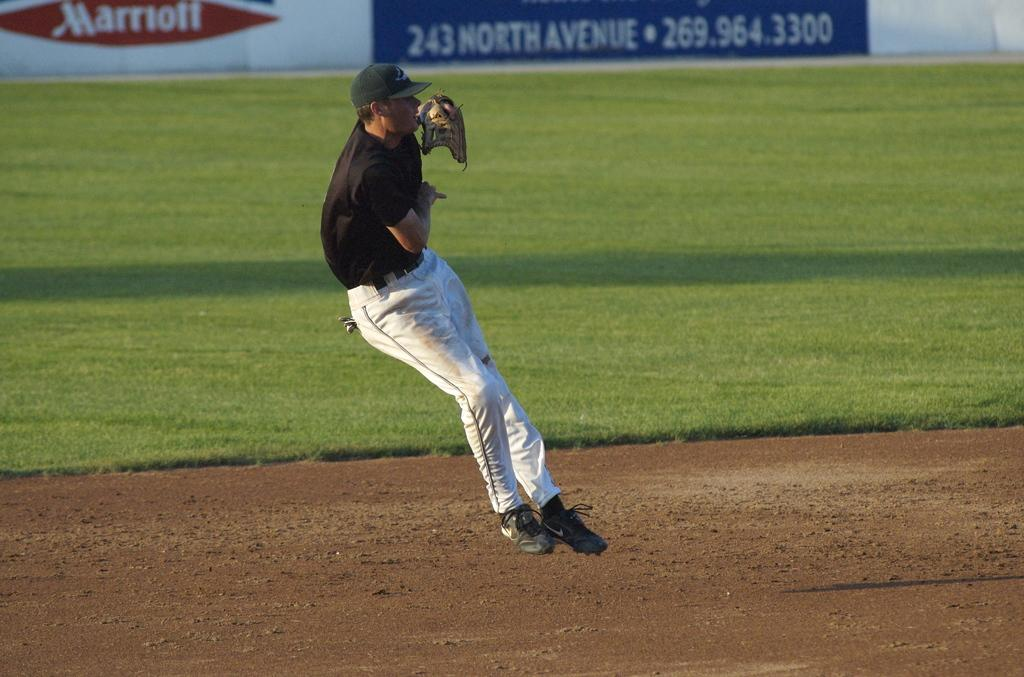<image>
Relay a brief, clear account of the picture shown. a player with a Marriott item in the back 